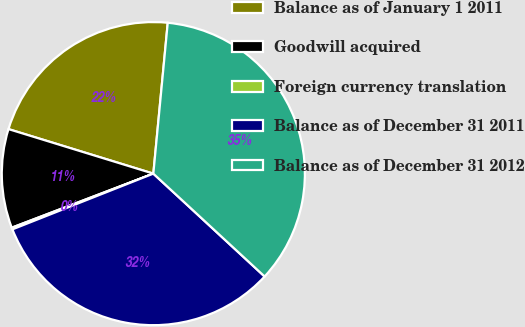<chart> <loc_0><loc_0><loc_500><loc_500><pie_chart><fcel>Balance as of January 1 2011<fcel>Goodwill acquired<fcel>Foreign currency translation<fcel>Balance as of December 31 2011<fcel>Balance as of December 31 2012<nl><fcel>21.77%<fcel>10.55%<fcel>0.19%<fcel>32.13%<fcel>35.36%<nl></chart> 